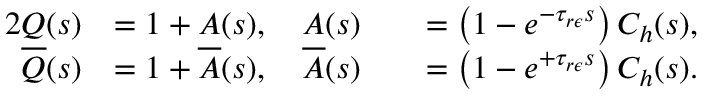<formula> <loc_0><loc_0><loc_500><loc_500>\begin{array} { r l r l } { { 2 } Q ( s ) } & { = 1 + A ( s ) , \quad A ( s ) } & & { = \left ( 1 - e ^ { - \tau _ { r \epsilon } s } \right ) C _ { h } ( s ) , } \\ { \overline { Q } ( s ) } & { = 1 + \overline { A } ( s ) , \quad \overline { A } ( s ) } & & { = \left ( 1 - e ^ { + \tau _ { r \epsilon } s } \right ) C _ { h } ( s ) . } \end{array}</formula> 